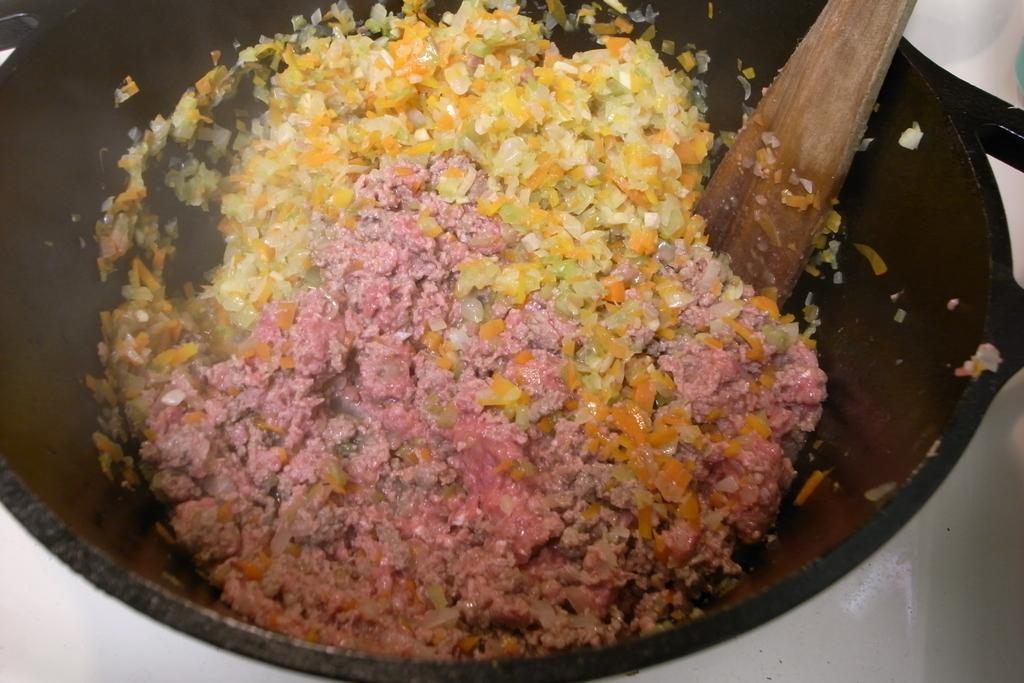What is in the bowl that is visible in the image? There is a bowl with food in the image. What utensil is present in the image? There is a spoon in the image. What condition is the writing in the image? There is no writing present in the image. What is the source of shame in the image? There is no shame present in the image. 